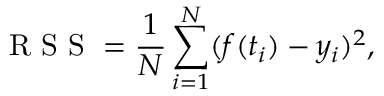<formula> <loc_0><loc_0><loc_500><loc_500>R S S = \frac { 1 } { N } \sum _ { i = 1 } ^ { N } ( f ( t _ { i } ) - y _ { i } ) ^ { 2 } ,</formula> 